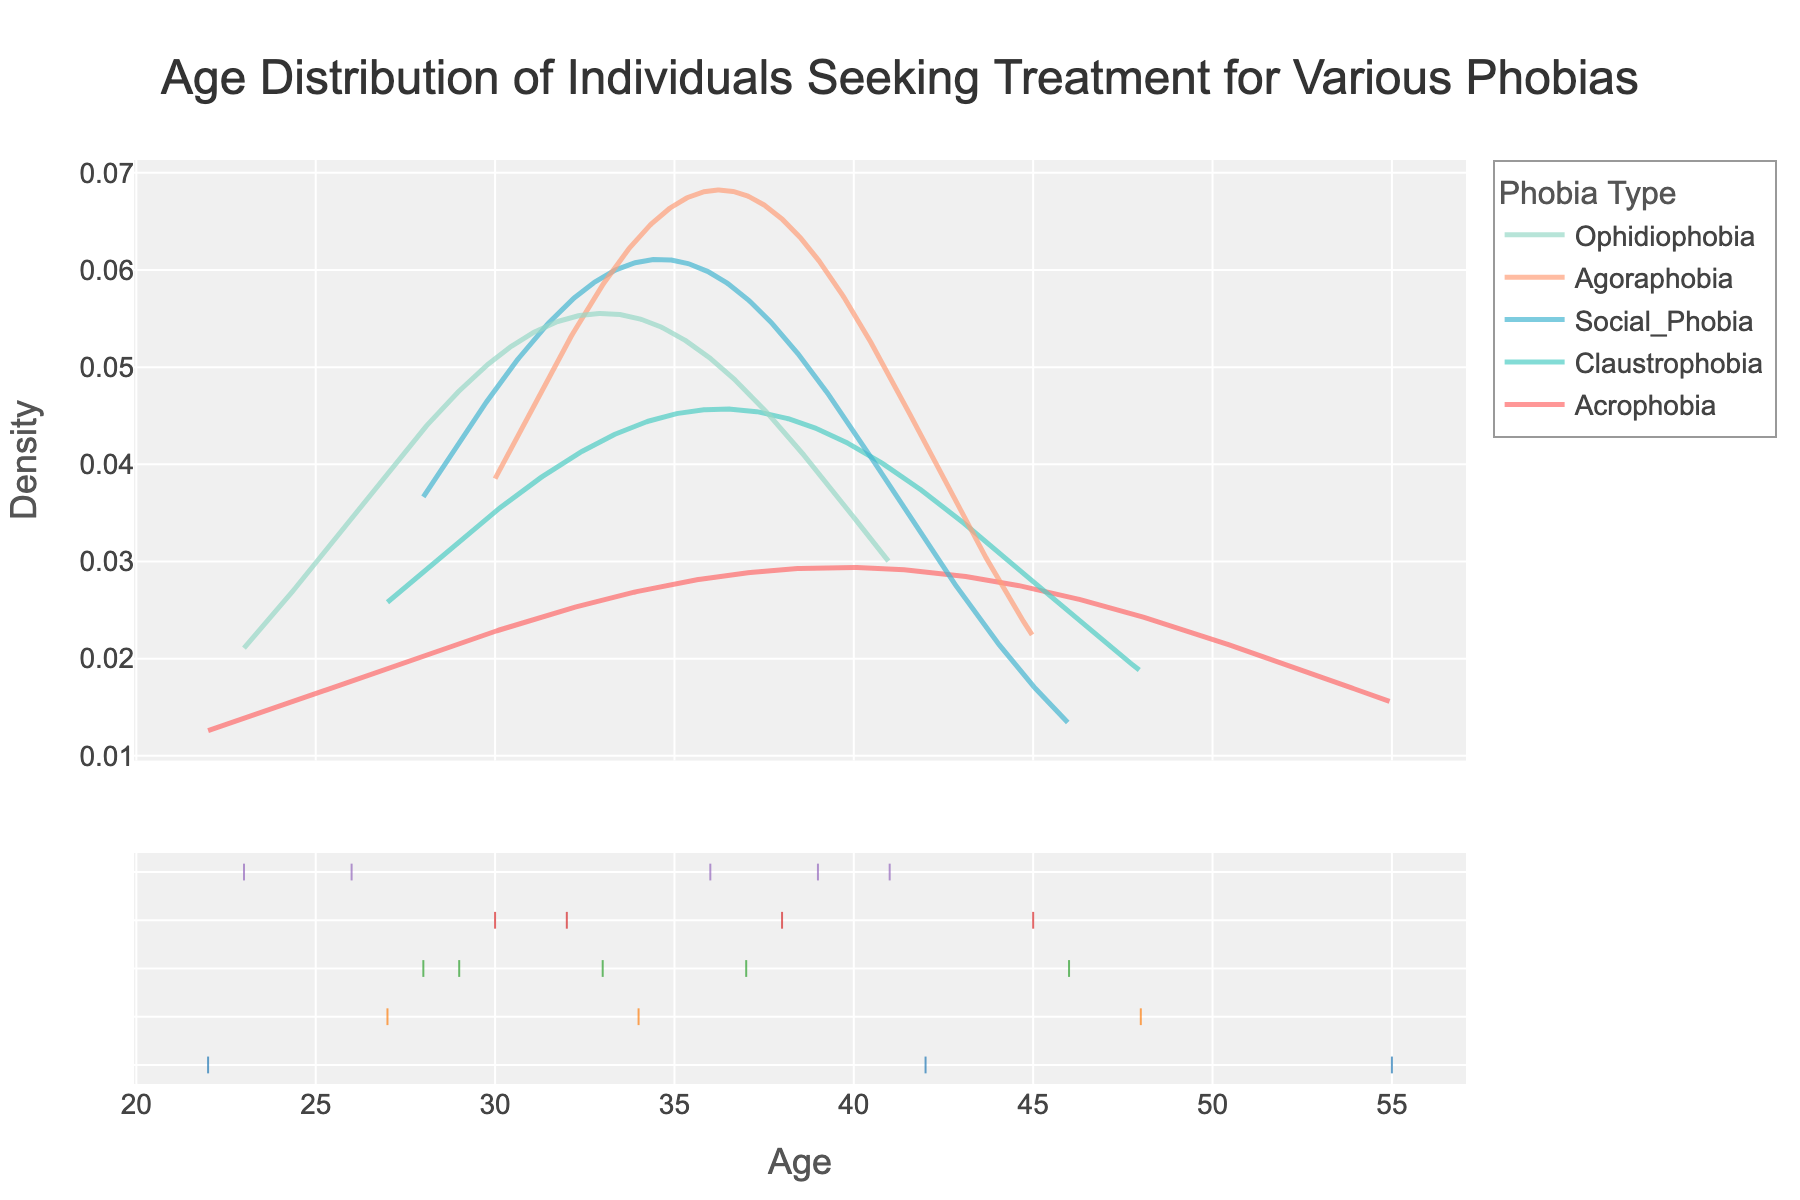What is the title of the figure? The title of the figure is located at the top and provides a summary of what the data represents. It provides context and usually conveys the main point of the data visualization.
Answer: Age Distribution of Individuals Seeking Treatment for Various Phobias What are the labels on the x-axis and y-axis? Labels on the x-axis and y-axis help identify what each axis represents. The x-axis label represents the variable 'Age,' and the y-axis label represents the variable 'Density.'
Answer: Age; Density Which phobia is represented by the color blue in the distribution plot? By examining the legend that maps colors to phobia types, you see that the color blue is associated with 'Ophidiophobia.'
Answer: Ophidiophobia Which phobia group has individuals with the widest age range seeking treatment? By comparing the distribution curves for each phobia, the phobia with the widest age range will show the broadest spread on the x-axis. 'Ophidiophobia' shows a wider range compared to other groups.
Answer: Ophidiophobia Out of all the phobia groups, which one has the highest peak in its density curve? The highest peak in the density curve indicates the age with the highest density of individuals seeking treatment. The 'Social_Phobia' group shows the highest peak on the density curve.
Answer: Social_Phobia Compare the peak age density between Acrophobia and Agoraphobia. Which one is higher? To identify which density curve peak is higher, compare the highest points (peaks) of the Acrophobia and Agoraphobia curves. The Agoraphobia group has a higher peak than the Acrophobia group.
Answer: Agoraphobia What is the approximate mean age for individuals with Claustrophobia based on the curve? The mean age can be estimated where the density curve has its central tendency. For the Claustrophobia group, the mean age appears around the mid-thirties.
Answer: Mid-thirties Between Ophidiophobia and Social_Phobia, which group has the younger age distribution peak? To determine which group has a younger age distribution peak, compare the X-axis locations of the peaks of both density curves. The Social_Phobia group has its peak distribution at a younger age compared to the Ophidiophobia group.
Answer: Social_Phobia Which phobia has the most even distribution of ages seeking treatment? The most evenly distributed phobia can be identified by the flatness and spread of its density curve. Claustrophobia's curve appears more evenly spread out over a range of ages.
Answer: Claustrophobia What is the overall trend observed in the age distribution among the different phobia types? To identify the overall trend, look at the general patterns in the density curves. Most phobias have age distributions concentrated in the late twenties to early forties, indicating this age range is common among those seeking treatment.
Answer: Late twenties to early forties 